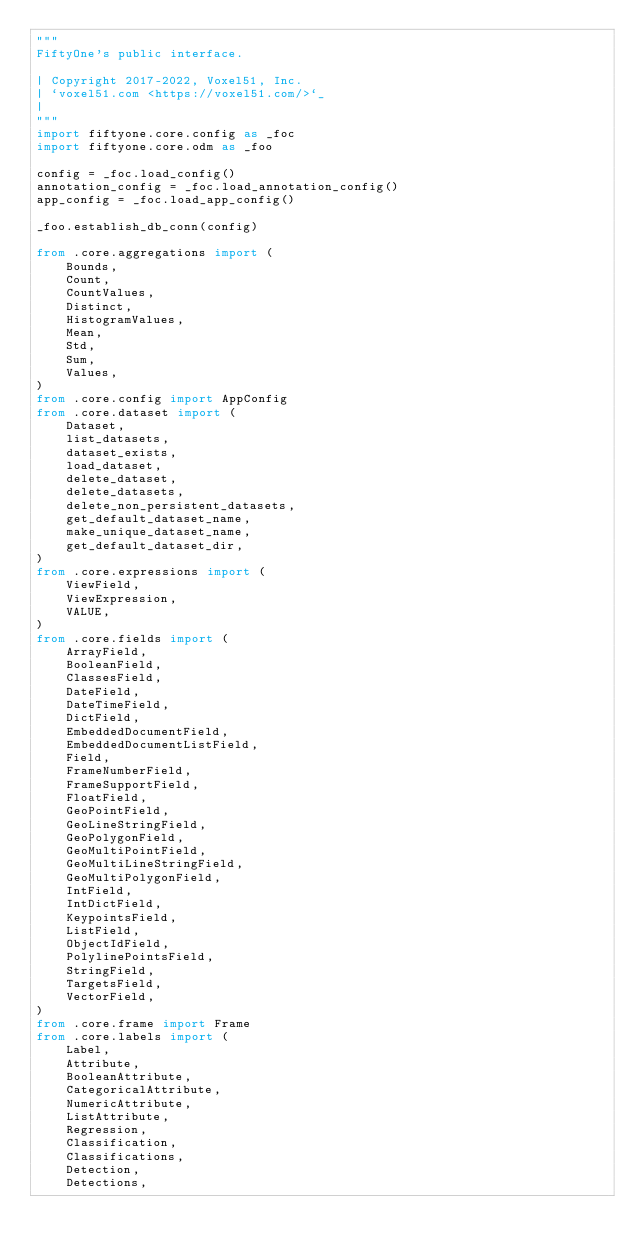<code> <loc_0><loc_0><loc_500><loc_500><_Python_>"""
FiftyOne's public interface.

| Copyright 2017-2022, Voxel51, Inc.
| `voxel51.com <https://voxel51.com/>`_
|
"""
import fiftyone.core.config as _foc
import fiftyone.core.odm as _foo

config = _foc.load_config()
annotation_config = _foc.load_annotation_config()
app_config = _foc.load_app_config()

_foo.establish_db_conn(config)

from .core.aggregations import (
    Bounds,
    Count,
    CountValues,
    Distinct,
    HistogramValues,
    Mean,
    Std,
    Sum,
    Values,
)
from .core.config import AppConfig
from .core.dataset import (
    Dataset,
    list_datasets,
    dataset_exists,
    load_dataset,
    delete_dataset,
    delete_datasets,
    delete_non_persistent_datasets,
    get_default_dataset_name,
    make_unique_dataset_name,
    get_default_dataset_dir,
)
from .core.expressions import (
    ViewField,
    ViewExpression,
    VALUE,
)
from .core.fields import (
    ArrayField,
    BooleanField,
    ClassesField,
    DateField,
    DateTimeField,
    DictField,
    EmbeddedDocumentField,
    EmbeddedDocumentListField,
    Field,
    FrameNumberField,
    FrameSupportField,
    FloatField,
    GeoPointField,
    GeoLineStringField,
    GeoPolygonField,
    GeoMultiPointField,
    GeoMultiLineStringField,
    GeoMultiPolygonField,
    IntField,
    IntDictField,
    KeypointsField,
    ListField,
    ObjectIdField,
    PolylinePointsField,
    StringField,
    TargetsField,
    VectorField,
)
from .core.frame import Frame
from .core.labels import (
    Label,
    Attribute,
    BooleanAttribute,
    CategoricalAttribute,
    NumericAttribute,
    ListAttribute,
    Regression,
    Classification,
    Classifications,
    Detection,
    Detections,</code> 